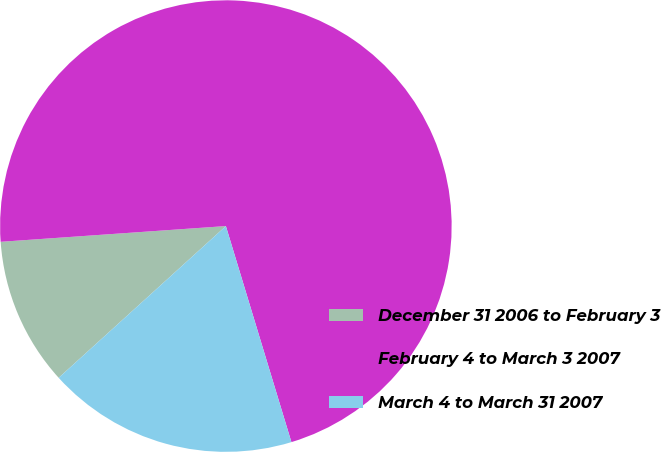<chart> <loc_0><loc_0><loc_500><loc_500><pie_chart><fcel>December 31 2006 to February 3<fcel>February 4 to March 3 2007<fcel>March 4 to March 31 2007<nl><fcel>10.62%<fcel>71.43%<fcel>17.96%<nl></chart> 